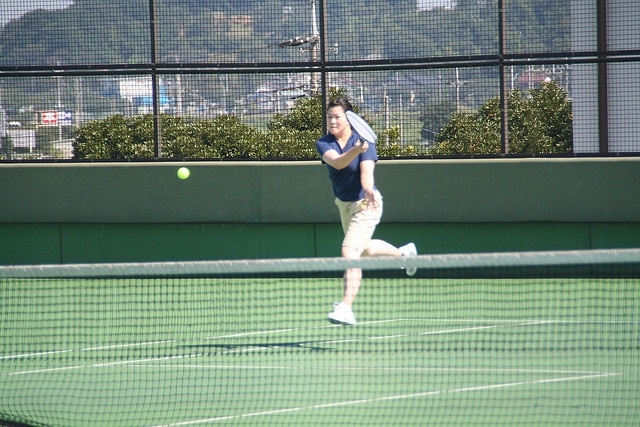Describe the objects in this image and their specific colors. I can see people in gray, white, darkgray, and black tones, tennis racket in gray, lavender, and darkgray tones, and sports ball in gray, beige, khaki, lightgreen, and green tones in this image. 